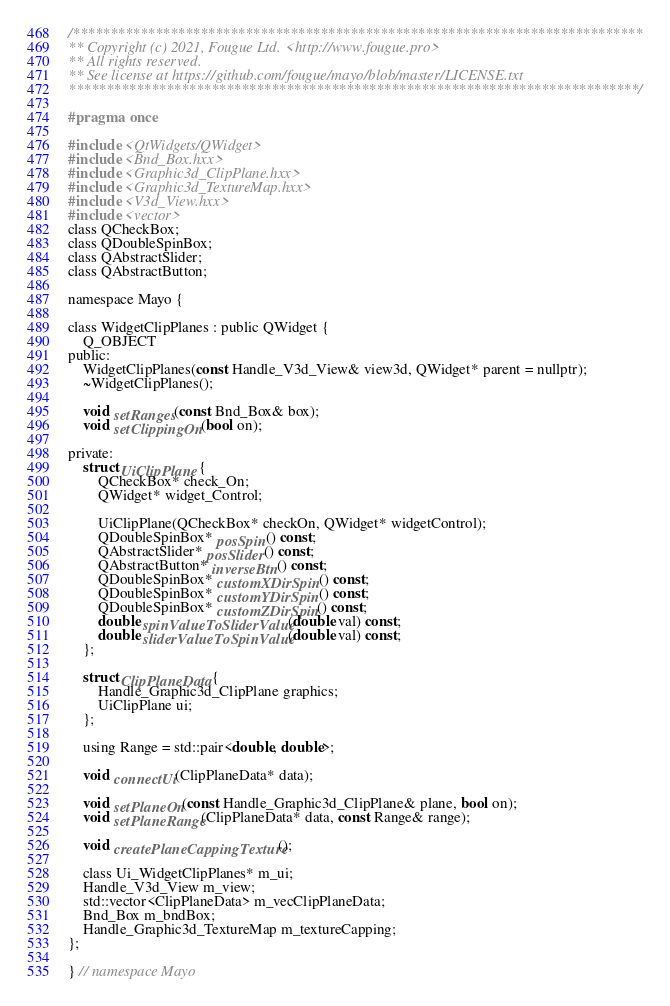Convert code to text. <code><loc_0><loc_0><loc_500><loc_500><_C_>/****************************************************************************
** Copyright (c) 2021, Fougue Ltd. <http://www.fougue.pro>
** All rights reserved.
** See license at https://github.com/fougue/mayo/blob/master/LICENSE.txt
****************************************************************************/

#pragma once

#include <QtWidgets/QWidget>
#include <Bnd_Box.hxx>
#include <Graphic3d_ClipPlane.hxx>
#include <Graphic3d_TextureMap.hxx>
#include <V3d_View.hxx>
#include <vector>
class QCheckBox;
class QDoubleSpinBox;
class QAbstractSlider;
class QAbstractButton;

namespace Mayo {

class WidgetClipPlanes : public QWidget {
    Q_OBJECT
public:
    WidgetClipPlanes(const Handle_V3d_View& view3d, QWidget* parent = nullptr);
    ~WidgetClipPlanes();

    void setRanges(const Bnd_Box& box);
    void setClippingOn(bool on);

private:
    struct UiClipPlane {
        QCheckBox* check_On;
        QWidget* widget_Control;

        UiClipPlane(QCheckBox* checkOn, QWidget* widgetControl);
        QDoubleSpinBox* posSpin() const;
        QAbstractSlider* posSlider() const;
        QAbstractButton* inverseBtn() const;
        QDoubleSpinBox* customXDirSpin() const;
        QDoubleSpinBox* customYDirSpin() const;
        QDoubleSpinBox* customZDirSpin() const;
        double spinValueToSliderValue(double val) const;
        double sliderValueToSpinValue(double val) const;
    };

    struct ClipPlaneData {
        Handle_Graphic3d_ClipPlane graphics;
        UiClipPlane ui;
    };

    using Range = std::pair<double, double>;

    void connectUi(ClipPlaneData* data);

    void setPlaneOn(const Handle_Graphic3d_ClipPlane& plane, bool on);
    void setPlaneRange(ClipPlaneData* data, const Range& range);

    void createPlaneCappingTexture();

    class Ui_WidgetClipPlanes* m_ui;
    Handle_V3d_View m_view;
    std::vector<ClipPlaneData> m_vecClipPlaneData;
    Bnd_Box m_bndBox;
    Handle_Graphic3d_TextureMap m_textureCapping;
};

} // namespace Mayo
</code> 